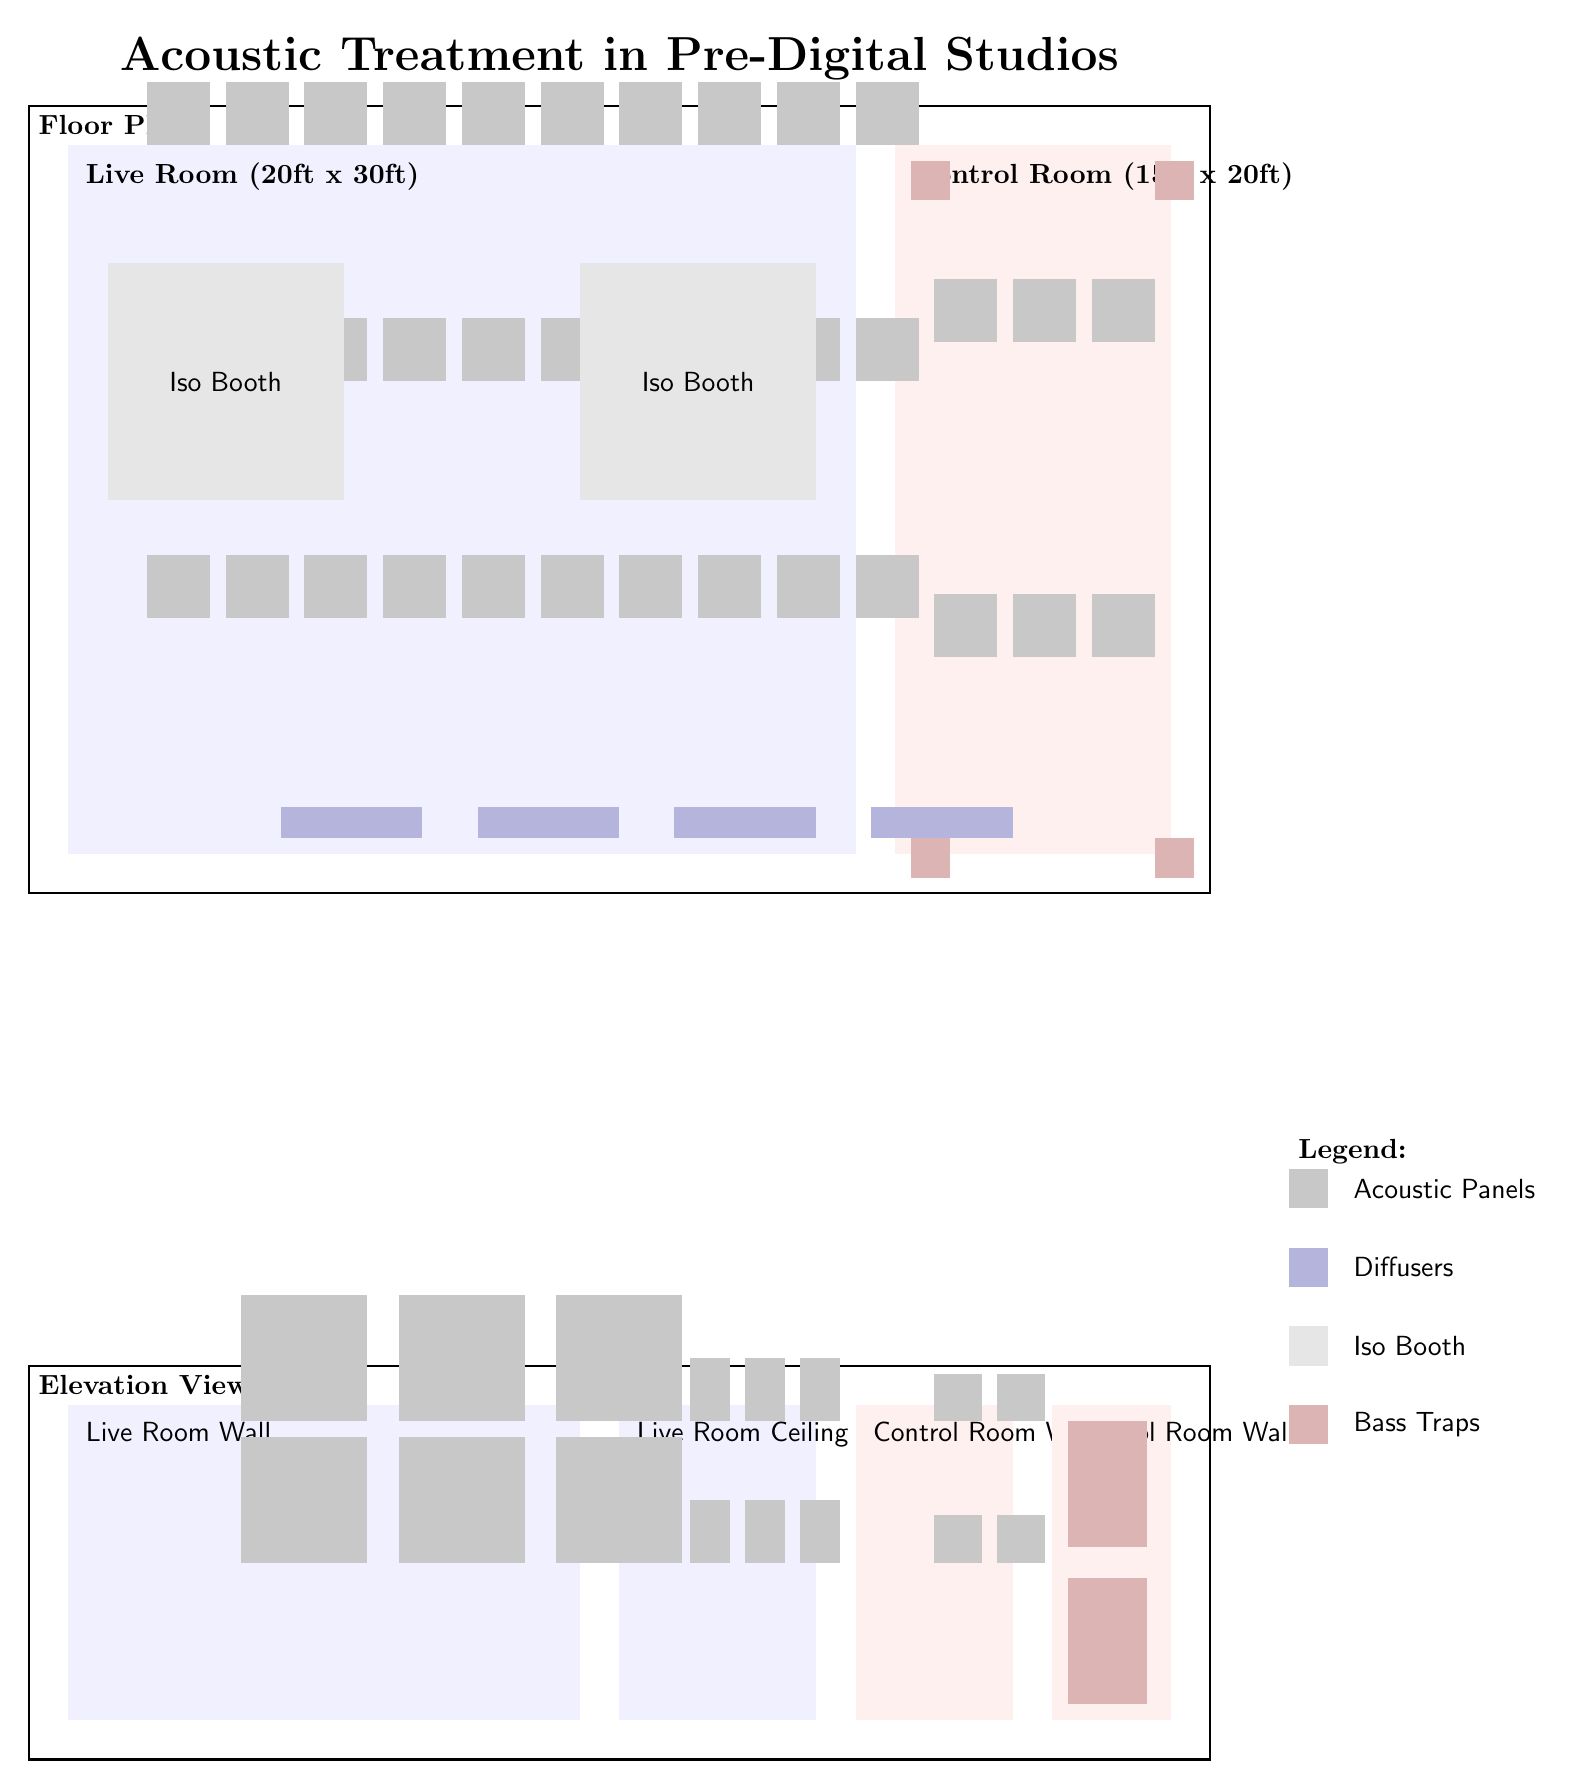what are the dimensions of the live room? The live room is specified in the diagram as having dimensions of 20ft x 30ft. These measurements can be found labeled within the live room area of the floor plan.
Answer: 20ft x 30ft how many isolation booths are present in the live room? There are 2 isolation booths shown in the live room area. Each booth is indicated by a rectangular shape with the label "Iso Booth" positioned inside.
Answer: 2 what color represents the acoustic panels in the diagram? The acoustic panels are represented by a gray shade in the diagram. This can be confirmed by observing the color legend on the right side of the diagram where different colors correspond to various elements.
Answer: gray where are the bass traps located in the control room? The bass traps are positioned at two specific locations on the control room walls, indicated clearly in the elevation view of the control room. They are found on the second wall, labeled “Control Room Wall 2,” near the bottom and upwards.
Answer: Control Room Wall 2 what purpose do diffusers serve in the studio? Diffusers are used to scatter sound waves, providing a more uniform sound field in the live room. This can be reasoned from their placement in the live room, as they help manage sound reflections and enhance overall acoustic quality.
Answer: scatter sound waves how many total acoustic panels are in the live room? There are 30 acoustic panels visible in the live room. This is calculated by counting them in rows (10 panels in 3 rows) that are evenly distributed along the walls of the live room area.
Answer: 30 which room has more acoustic panels, the live room or the control room? The live room has more acoustic panels. By comparing the number of panels in each room (30 in live room vs. 6 in control room), the conclusion can be made that the live room has a greater quantity.
Answer: live room how many bass traps are located on the control room wall? There are 2 bass traps located on the control room wall, specifically on Control Room Wall 2 as shown in the elevation view section of the diagram.
Answer: 2 what is the overall title of the diagram? The title of the diagram is presented at the top, stating “Acoustic Treatment in Pre-Digital Studios.” This concise title introduces the main theme of the diagram.
Answer: Acoustic Treatment in Pre-Digital Studios 